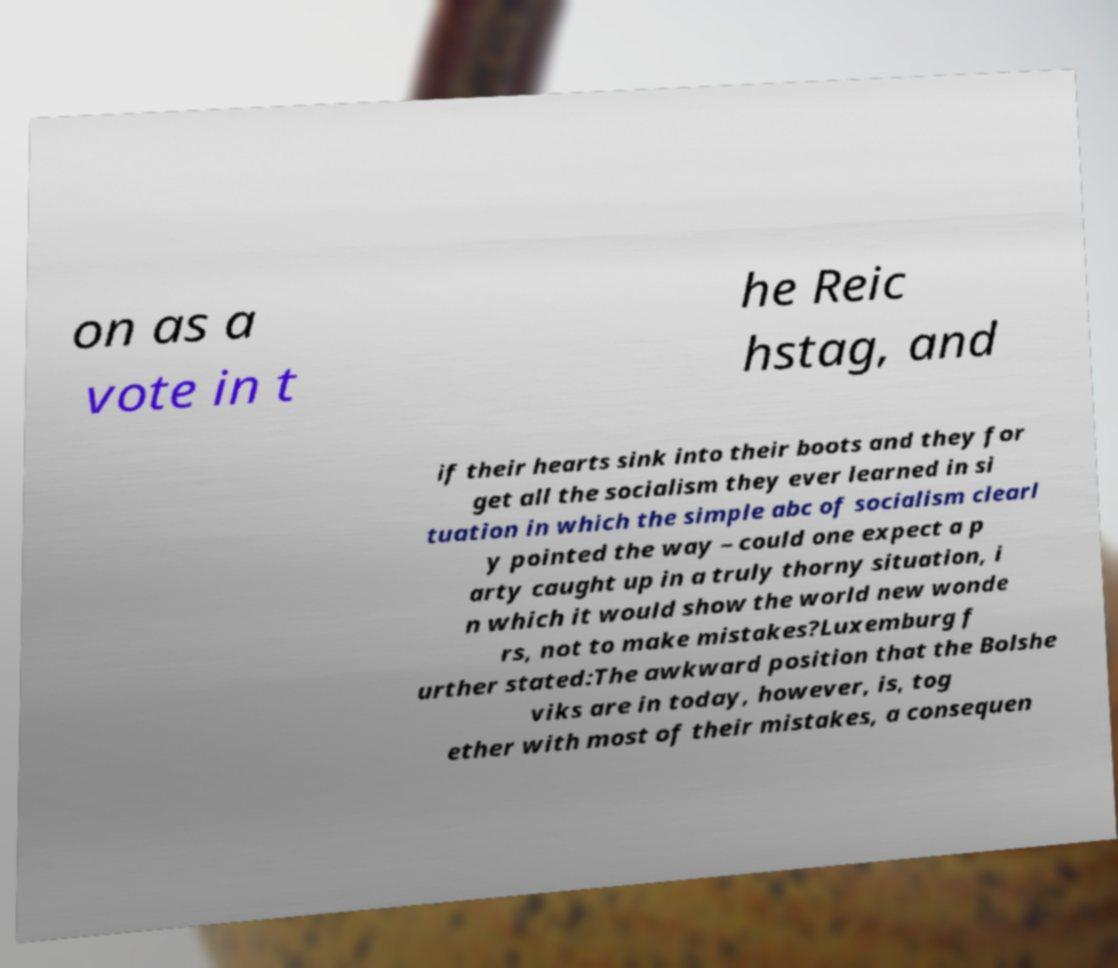Please identify and transcribe the text found in this image. on as a vote in t he Reic hstag, and if their hearts sink into their boots and they for get all the socialism they ever learned in si tuation in which the simple abc of socialism clearl y pointed the way – could one expect a p arty caught up in a truly thorny situation, i n which it would show the world new wonde rs, not to make mistakes?Luxemburg f urther stated:The awkward position that the Bolshe viks are in today, however, is, tog ether with most of their mistakes, a consequen 